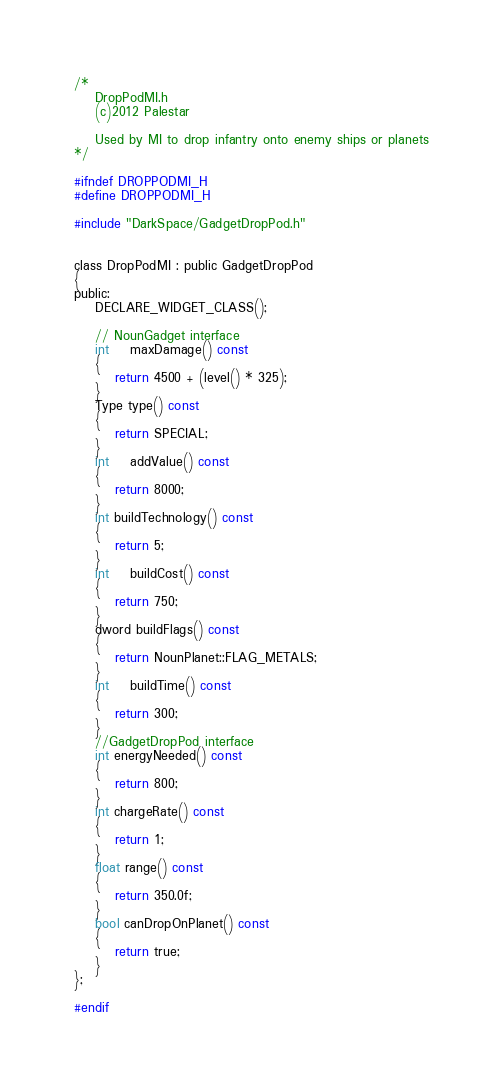Convert code to text. <code><loc_0><loc_0><loc_500><loc_500><_C_>/*	
	DropPodMI.h
	(c)2012 Palestar

	Used by MI to drop infantry onto enemy ships or planets
*/

#ifndef DROPPODMI_H
#define DROPPODMI_H

#include "DarkSpace/GadgetDropPod.h"


class DropPodMI : public GadgetDropPod
{
public:
	DECLARE_WIDGET_CLASS();

	// NounGadget interface
	int	maxDamage() const
	{
		return 4500 + (level() * 325);
	}
	Type type() const
	{
		return SPECIAL;
	}
	int	addValue() const
	{
		return 8000;
	}
	int buildTechnology() const
	{
		return 5;
	}
	int	buildCost() const
	{
		return 750;
	}
	dword buildFlags() const
	{
		return NounPlanet::FLAG_METALS;
	}
	int	buildTime() const
	{
		return 300;
	}
	//GadgetDropPod interface
	int energyNeeded() const
	{
		return 800;
	}
	int chargeRate() const
	{
		return 1;
	}
	float range() const
	{
		return 350.0f;
	}
	bool canDropOnPlanet() const
	{
		return true;
	}
};

#endif
</code> 